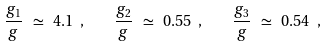Convert formula to latex. <formula><loc_0><loc_0><loc_500><loc_500>\frac { g _ { 1 } } { g } \ \simeq \ 4 . 1 \ , \quad \frac { g _ { 2 } } { g } \ \simeq \ 0 . 5 5 \ , \quad \frac { g _ { 3 } } { g } \ \simeq \ 0 . 5 4 \ ,</formula> 